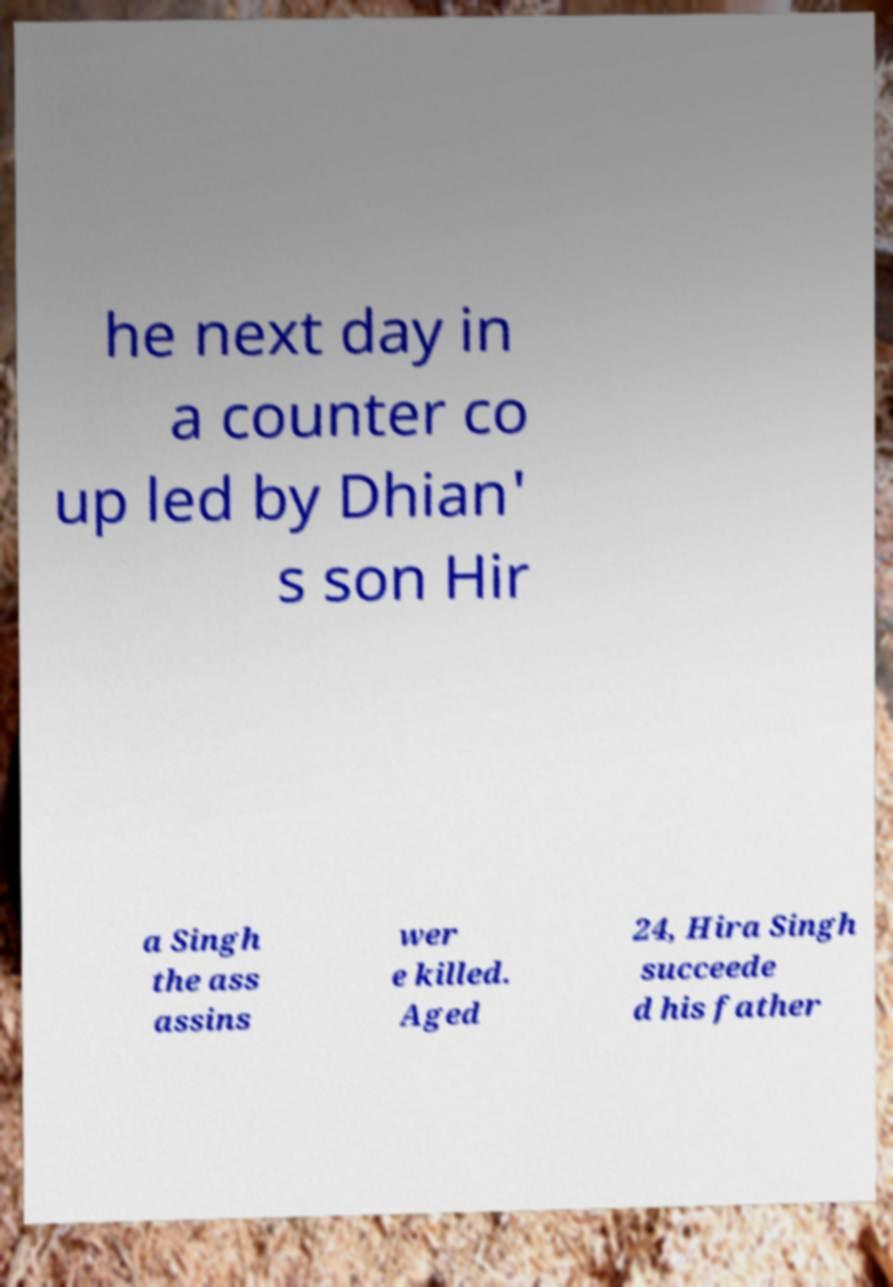Can you accurately transcribe the text from the provided image for me? he next day in a counter co up led by Dhian' s son Hir a Singh the ass assins wer e killed. Aged 24, Hira Singh succeede d his father 